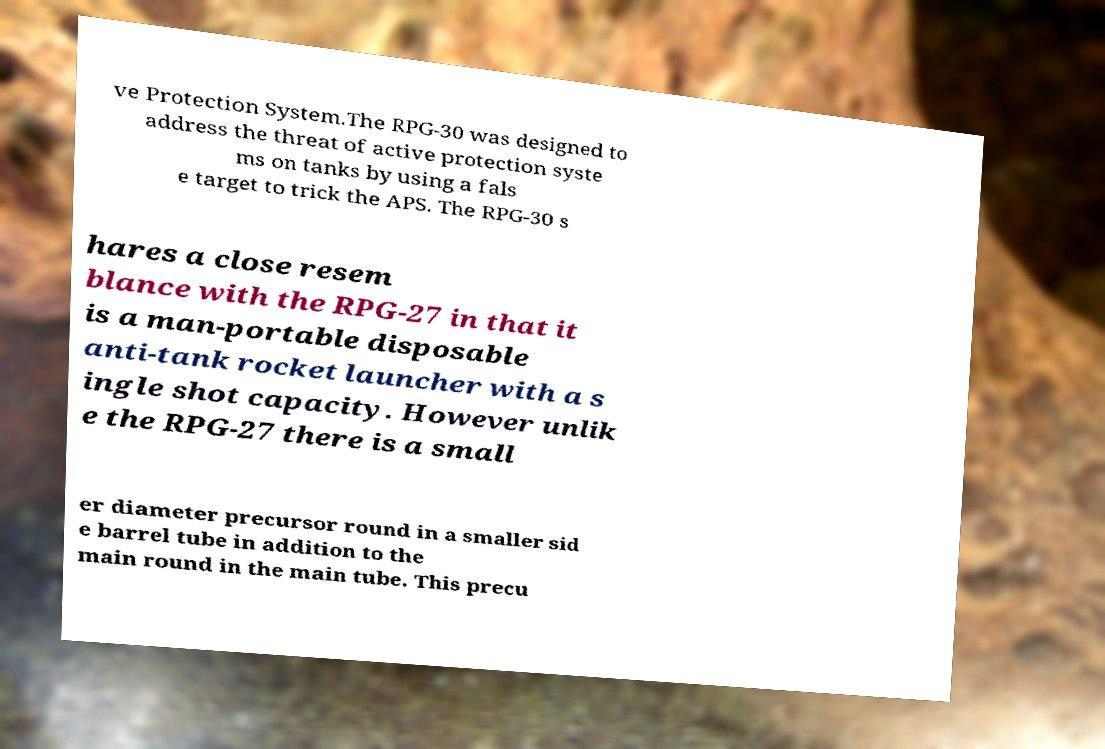What messages or text are displayed in this image? I need them in a readable, typed format. ve Protection System.The RPG-30 was designed to address the threat of active protection syste ms on tanks by using a fals e target to trick the APS. The RPG-30 s hares a close resem blance with the RPG-27 in that it is a man-portable disposable anti-tank rocket launcher with a s ingle shot capacity. However unlik e the RPG-27 there is a small er diameter precursor round in a smaller sid e barrel tube in addition to the main round in the main tube. This precu 